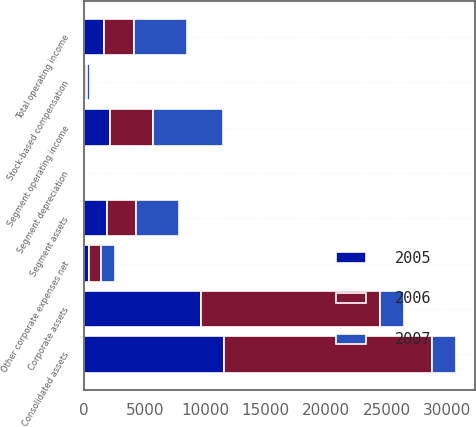<chart> <loc_0><loc_0><loc_500><loc_500><stacked_bar_chart><ecel><fcel>Segment operating income<fcel>Other corporate expenses net<fcel>Stock-based compensation<fcel>Total operating income<fcel>Segment assets<fcel>Corporate assets<fcel>Consolidated assets<fcel>Segment depreciation<nl><fcel>2007<fcel>5792<fcel>1141<fcel>242<fcel>4409<fcel>3588<fcel>1988.5<fcel>1988.5<fcel>109<nl><fcel>2006<fcel>3569<fcel>953<fcel>163<fcel>2453<fcel>2379<fcel>14826<fcel>17205<fcel>75<nl><fcel>2005<fcel>2096<fcel>404<fcel>49<fcel>1643<fcel>1881<fcel>9635<fcel>11516<fcel>58<nl></chart> 